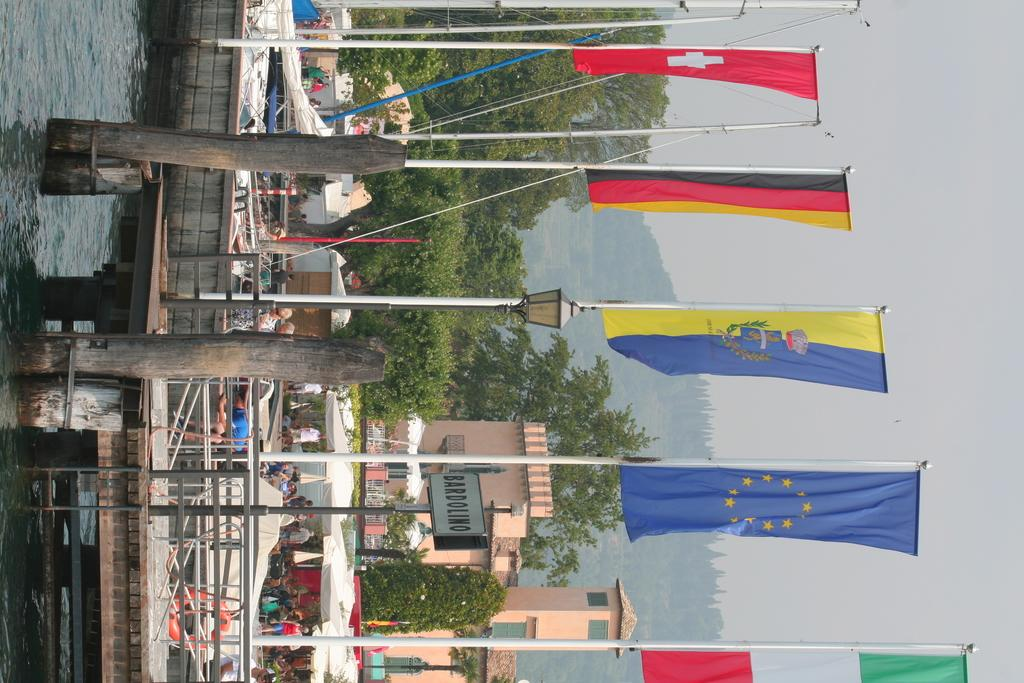What is present in the image that represents a body of water? There is water in the image. What can be seen flying in the image? There are flags in the image. Who or what is present in the image that indicates human presence? There are people in the image. What type of vegetation is visible in the image? There are trees in the image. What type of structures are visible in the image? There are buildings in the image. What type of lighting is present in the image? There is a street lamp in the image. What part of the sky is visible in the image? The sky is visible on the right side of the image. What type of silver print can be seen on the ground in the image? There is no silver print present in the image. How many feet are visible in the image? There is no mention of feet or any body parts in the image. 